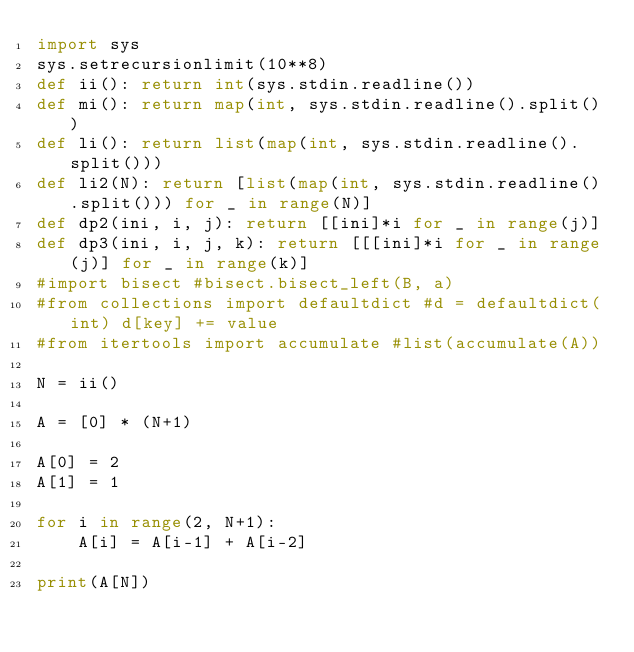Convert code to text. <code><loc_0><loc_0><loc_500><loc_500><_Python_>import sys
sys.setrecursionlimit(10**8)
def ii(): return int(sys.stdin.readline())
def mi(): return map(int, sys.stdin.readline().split())
def li(): return list(map(int, sys.stdin.readline().split()))
def li2(N): return [list(map(int, sys.stdin.readline().split())) for _ in range(N)]
def dp2(ini, i, j): return [[ini]*i for _ in range(j)]
def dp3(ini, i, j, k): return [[[ini]*i for _ in range(j)] for _ in range(k)]
#import bisect #bisect.bisect_left(B, a)
#from collections import defaultdict #d = defaultdict(int) d[key] += value
#from itertools import accumulate #list(accumulate(A))

N = ii()

A = [0] * (N+1)

A[0] = 2
A[1] = 1

for i in range(2, N+1):
    A[i] = A[i-1] + A[i-2]

print(A[N])</code> 